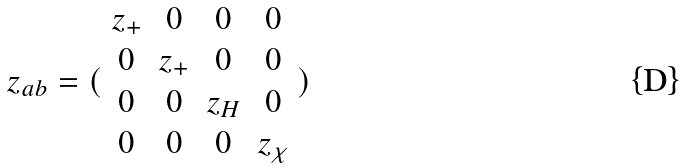Convert formula to latex. <formula><loc_0><loc_0><loc_500><loc_500>z _ { a b } = ( \begin{array} { c c c c } z _ { + } & 0 & 0 & 0 \\ 0 & z _ { + } & 0 & 0 \\ 0 & 0 & z _ { H } & 0 \\ 0 & 0 & 0 & z _ { \chi } \end{array} )</formula> 